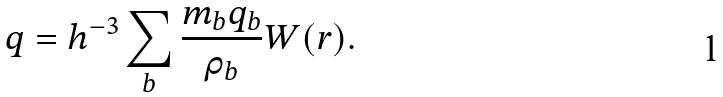<formula> <loc_0><loc_0><loc_500><loc_500>q = h ^ { - 3 } \sum _ { b } \frac { m _ { b } q _ { b } } { \rho _ { b } } W ( r ) .</formula> 